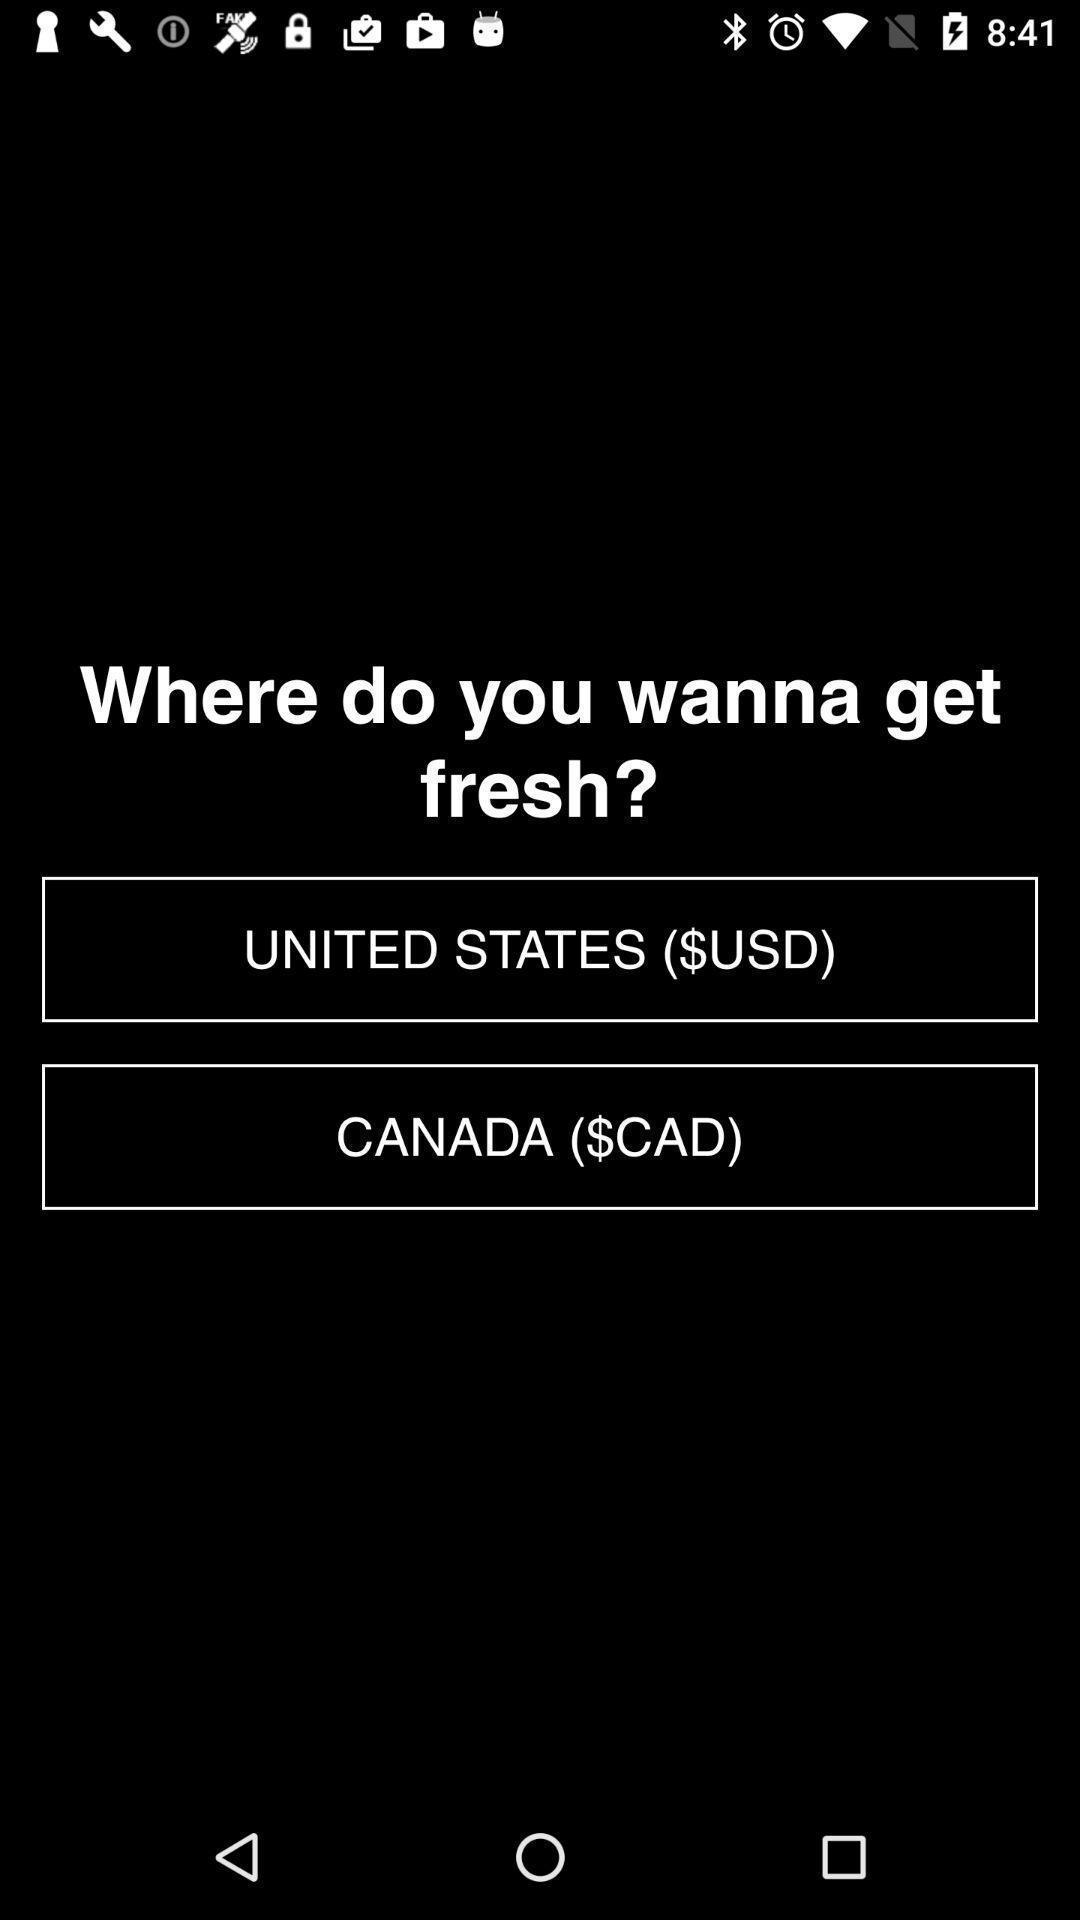Describe this image in words. Page showing two country options. 